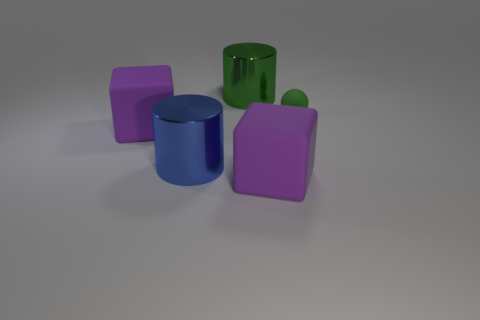What number of other things are there of the same size as the green shiny cylinder?
Offer a terse response. 3. Are there more tiny green rubber objects in front of the small green ball than small red shiny balls?
Offer a very short reply. No. Is the blue shiny cylinder the same size as the green cylinder?
Your answer should be compact. Yes. What material is the other big thing that is the same shape as the big green thing?
Offer a terse response. Metal. How many blue things are metal objects or tiny objects?
Your response must be concise. 1. What material is the big cylinder to the left of the big green thing?
Keep it short and to the point. Metal. Is the number of tiny green matte things greater than the number of large objects?
Make the answer very short. No. Does the green thing left of the green rubber object have the same shape as the blue shiny thing?
Offer a very short reply. Yes. What number of objects are both behind the large blue shiny cylinder and in front of the big green metallic object?
Provide a succinct answer. 2. What number of large purple rubber things are the same shape as the large blue thing?
Keep it short and to the point. 0. 